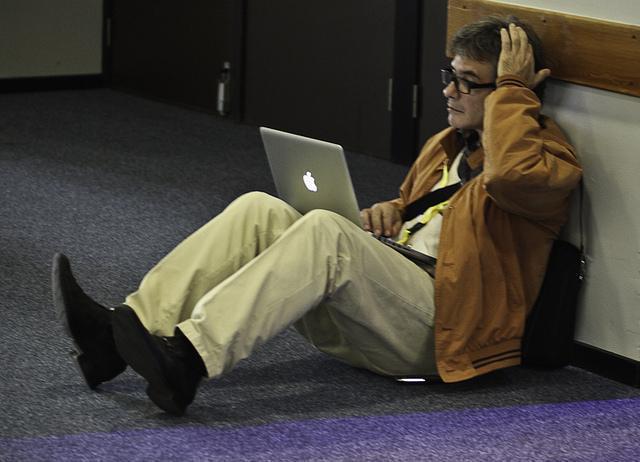Why is this man sitting down?
Pick the correct solution from the four options below to address the question.
Options: To drink, to eat, to rest, to work. To work. 